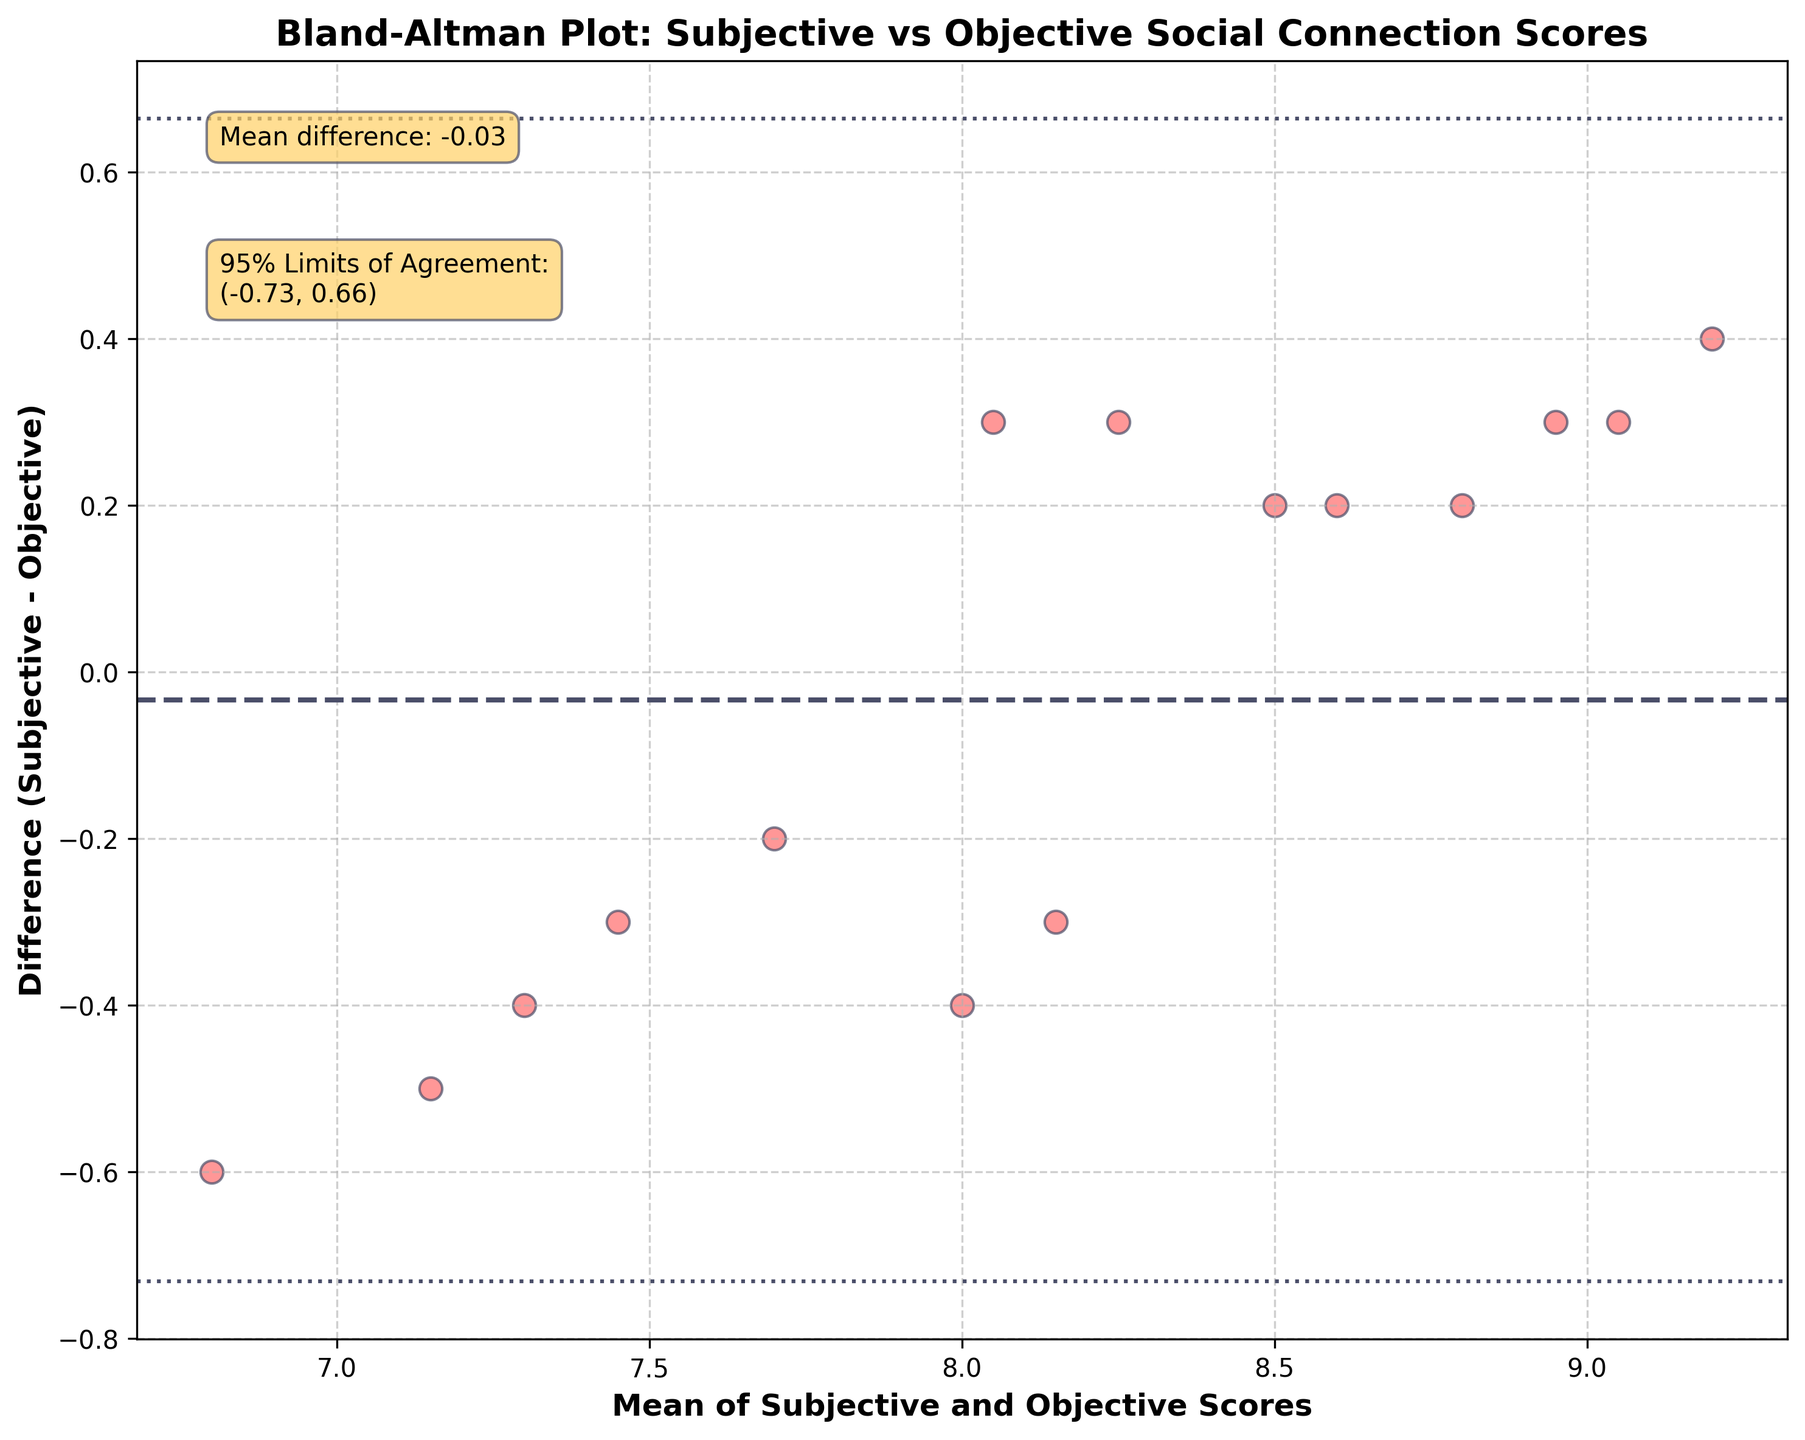What's the title of the plot? The title of the plot is usually located at the top center of the graph. In this case, the title reads "Bland-Altman Plot: Subjective vs Objective Social Connection Scores."
Answer: Bland-Altman Plot: Subjective vs Objective Social Connection Scores What do the x-axis and y-axis represent in this plot? The x-axis represents the "Mean of Subjective and Objective Scores," while the y-axis represents the "Difference (Subjective - Objective)." This information is typically found on the respective axis labels.
Answer: Mean of Subjective and Objective Scores, Difference (Subjective - Objective) How many data points are plotted in this Bland-Altman plot? To determine the number of data points, count the number of individual scatter points present in the plot.
Answer: 15 What is the mean difference shown in the plot? The mean difference is displayed as a horizontal dashed line and indicated by a text annotation on the plot. According to the annotation, it is 0.27.
Answer: 0.27 What are the 95% limits of agreement indicated on the plot? The 95% limits of agreement are represented by two horizontal dotted lines, and their values are annotated on the plot. The limits are approximately (0.27 - 1.96 * 0.58, 0.27 + 1.96 * 0.58), which are given explicitly as -0.87 to 1.42.
Answer: (-0.87, 1.42) What can you say about the overall bias observed between subjective and objective scores? The overall bias, represented by the mean difference, indicates that, on average, the subjective scores are 0.27 units higher than the objective scores. This can be inferred from the position of the mean difference line, which is above zero on the y-axis.
Answer: Subjective scores are 0.27 units higher Which participant most likely has the highest difference between subjective and objective scores? To identify the participant with the highest difference, find the furthest data point from the y=0 line on the plot. In this case, the largest difference is around 0.4-0.5, which corresponds to Maria Garcia, since her subjective score is 0.4 higher than her objective score according to the data.
Answer: Maria Garcia Is there any visible trend in the differences as the mean scores increase or decrease? In a Bland-Altman plot, one might look for patterns such as a funnel shape or a linear trend. In this case, the scatter points are spread relatively evenly across the mean values, indicating no clear trend between the differences and the mean scores.
Answer: No clear trend What does a point above the mean difference line represent in this plot? A point above the mean difference line signifies that for that specific participant, the subjective score is higher than the objective score by an amount greater than the average mean difference (0.27).
Answer: Subjective score higher than objective score by more than 0.27 Are there any points outside the 95% limits of agreement? To determine this, check if any of the scatter points lie beyond the two dotted horizontal lines representing the 95% limits of agreement. In this case, all points lie within these limits.
Answer: No 